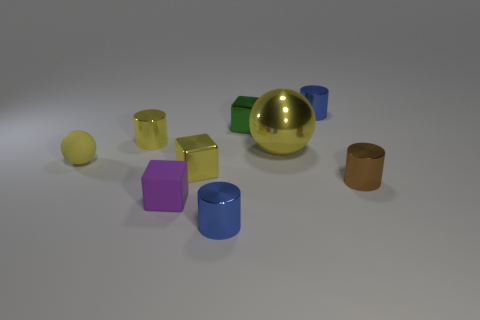Could you speculate on the purpose of this arrangement of objects? This arrangement of objects might serve an educational or demonstrative purpose, perhaps to show different geometric shapes, colors, and materials in a simple yet visually engaging composition. It could also be an artistic display, with the intention to create a visually pleasing balance of forms and hues. 